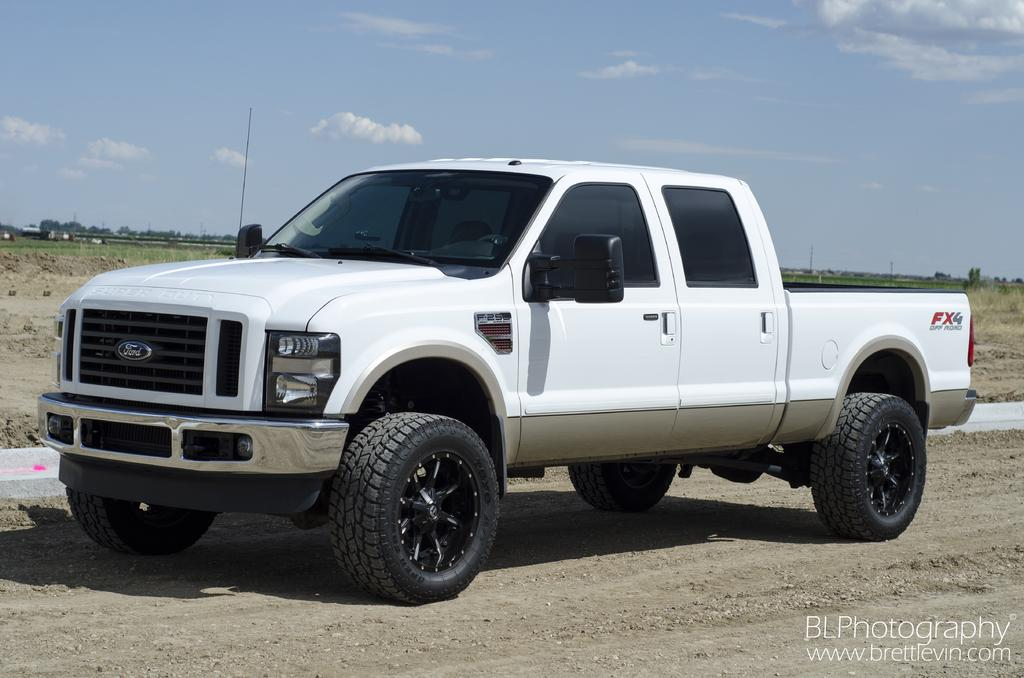What is the main subject of the image? There is a vehicle in the image. Can you describe the vehicle's position? The vehicle is on a surface. What type of natural elements can be seen in the image? There are trees visible in the image. What is visible in the sky? Clouds are present in the sky. What type of wool is being used to make the soup in the image? There is no wool or soup present in the image; it features a vehicle on a surface with trees and clouds visible. 